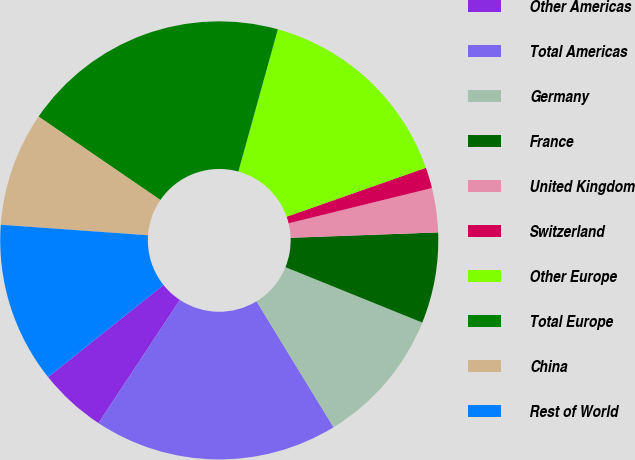Convert chart to OTSL. <chart><loc_0><loc_0><loc_500><loc_500><pie_chart><fcel>Other Americas<fcel>Total Americas<fcel>Germany<fcel>France<fcel>United Kingdom<fcel>Switzerland<fcel>Other Europe<fcel>Total Europe<fcel>China<fcel>Rest of World<nl><fcel>4.98%<fcel>18.03%<fcel>10.14%<fcel>6.7%<fcel>3.26%<fcel>1.54%<fcel>15.31%<fcel>19.75%<fcel>8.42%<fcel>11.86%<nl></chart> 